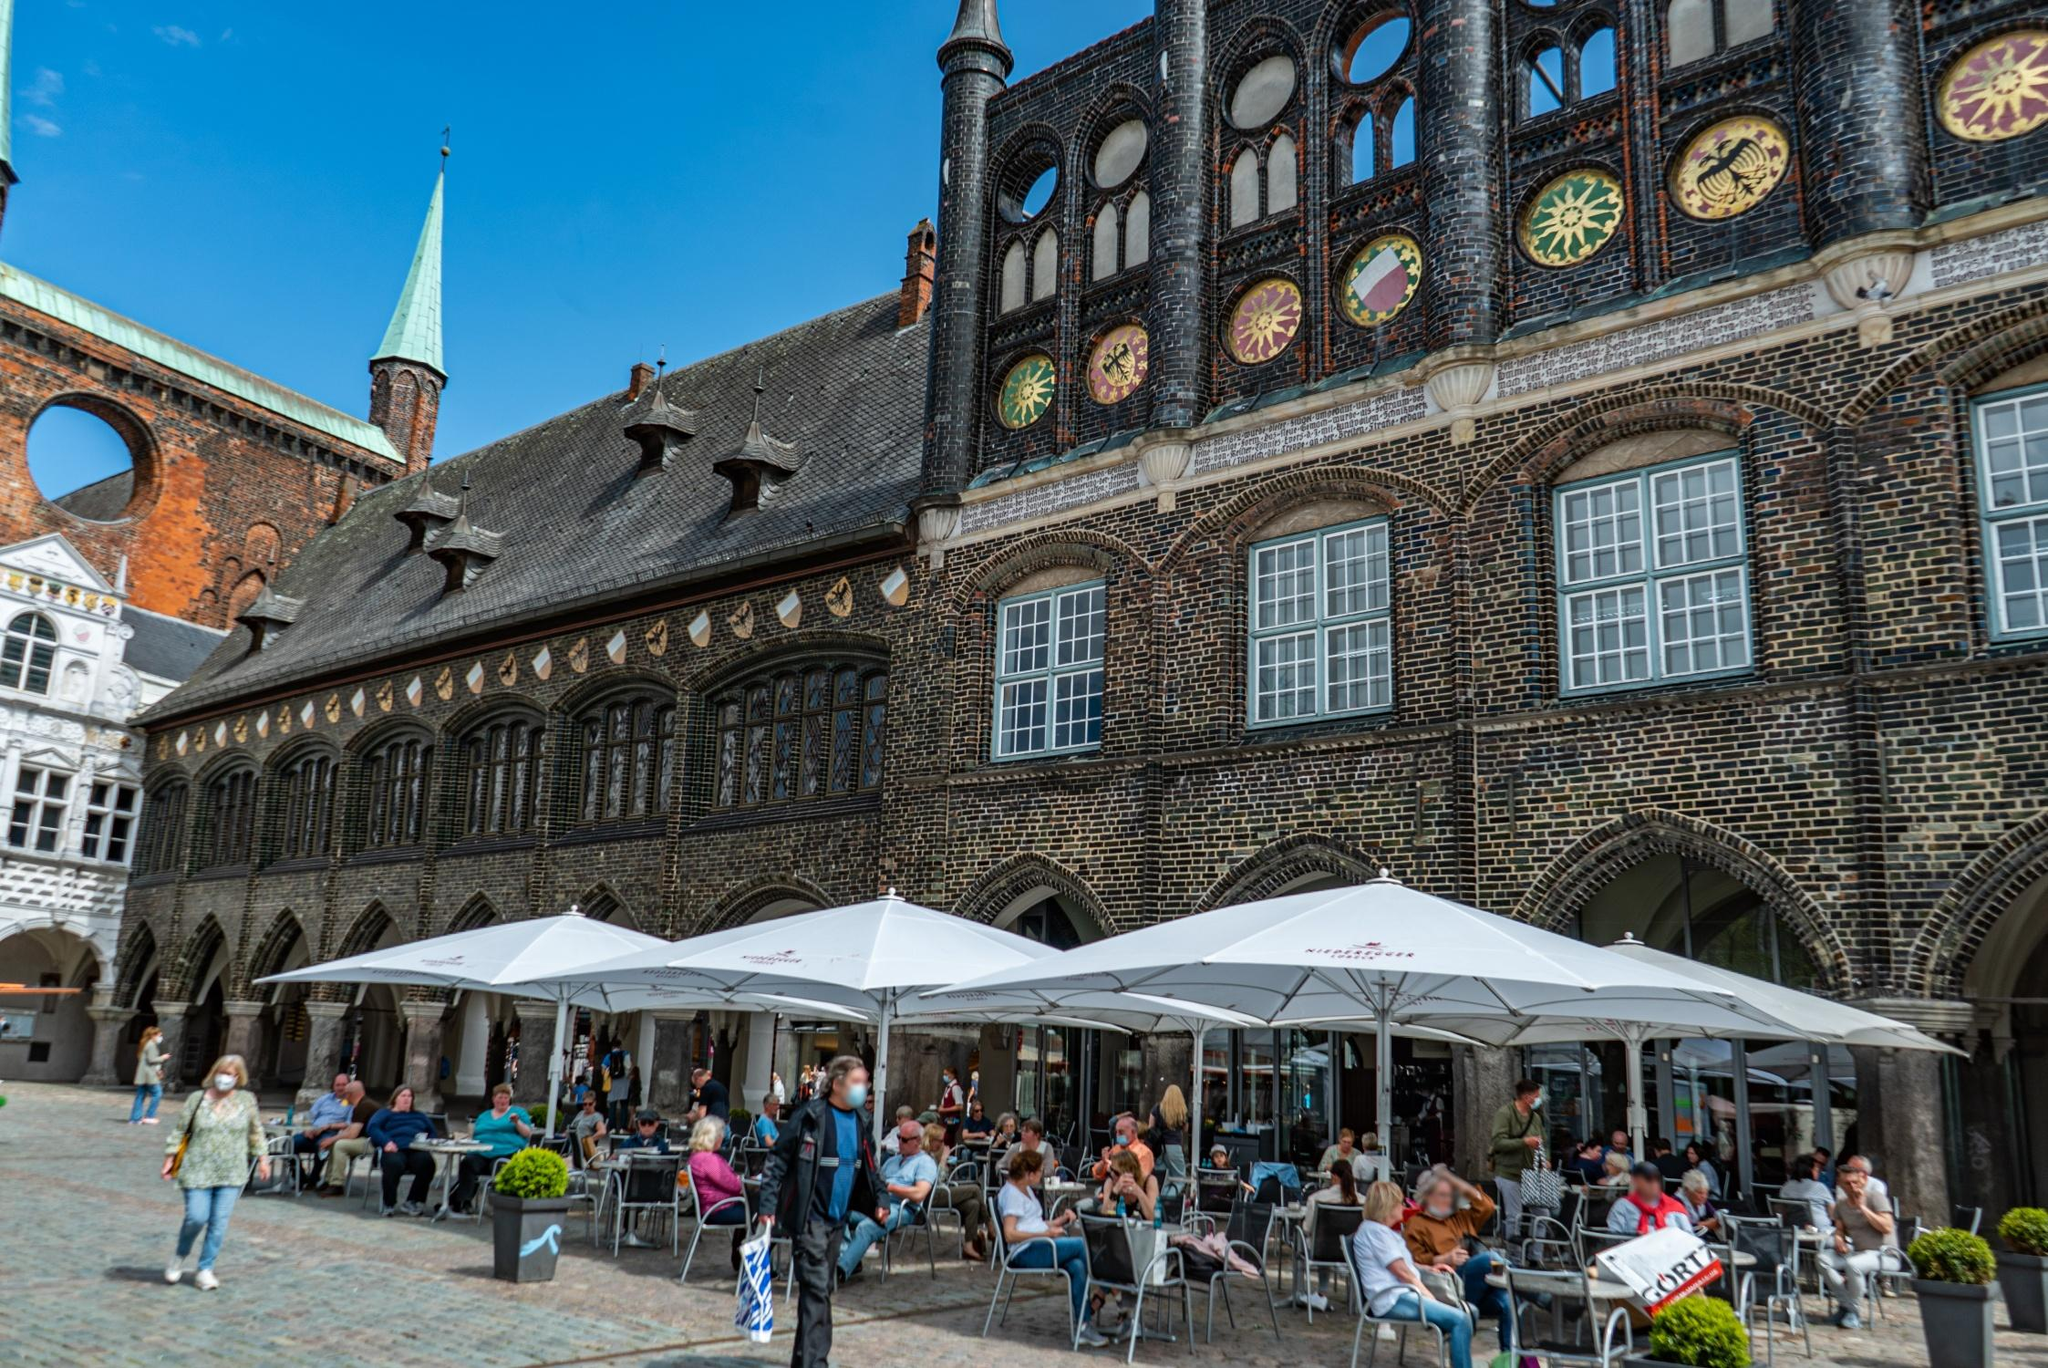Imagine you are visiting this place on a sunny afternoon. Describe your experience. Visiting the Lübeck Town Hall on a sunny afternoon is a delightful experience. The clear blue sky highlights the intricate details of the dark brick facade and colorful circular windows. The green spire glistens in the sunlight, creating a picturesque contrast with the historic architecture. The square is alive with activity, filled with locals and tourists enjoying their time at the outdoor café. You decide to sit under one of the large white umbrellas and order a coffee while taking in the vibrant scene. The aroma of freshly baked pastries from nearby stalls wafts through the air, adding to the pleasant ambiance. Street musicians add a background score with light tunes, enhancing the experience. The warmth of the sun combined with the lively atmosphere provides a perfect setting for an afternoon of relaxation and admiration of the town's historical charm. Write a short scenario as if you are visiting this place during a historical event. Attending a Hanseatic League meeting at the Lübeck Town Hall in the 14th century, you are surrounded by merchants and dignitaries from across Europe. The square is bustling with activity as representatives discuss trade routes and economic policies. You stand in awe of the grandeur of the town hall, its Gothic architecture reflecting the city's prosperity. Walking through the halls, you can hear heated debates and negotiations, a testament to Lübeck's pivotal role in medieval commerce.  If you could meet anybody here, who would it be and why? If I could meet anyone at the Lübeck Town Hall, I would choose to meet a Hanseatic League merchant from the 14th century. Engaging with someone who experienced the height of Lübeck's mercantile power firsthand would provide fascinating insights into the trade networks, economic challenges, and daily life during that period. Understanding their perspectives on commerce, navigation, and the socio-political climate of the time would be incredibly enriching and enlightening. Imagine there's a hidden treasure in this building. How would you go about finding it? If there were a hidden treasure in the Lübeck Town Hall, the quest to find it would be thrilling. I would start by researching historical documents and maps for any clues or legends suggesting its existence. Exploring every nook and cranny, I would look for hidden compartments in the intricate woodwork and stone carvings. The colorful circular windows with their unique designs might hold valuable clues, as could the clock and spire, which may have secret passages or hidden chambers. Teaming up with historians and architects, we would unravel the centuries-old mysteries encoded in the building's structure, hoping to uncover the long-lost treasure. 